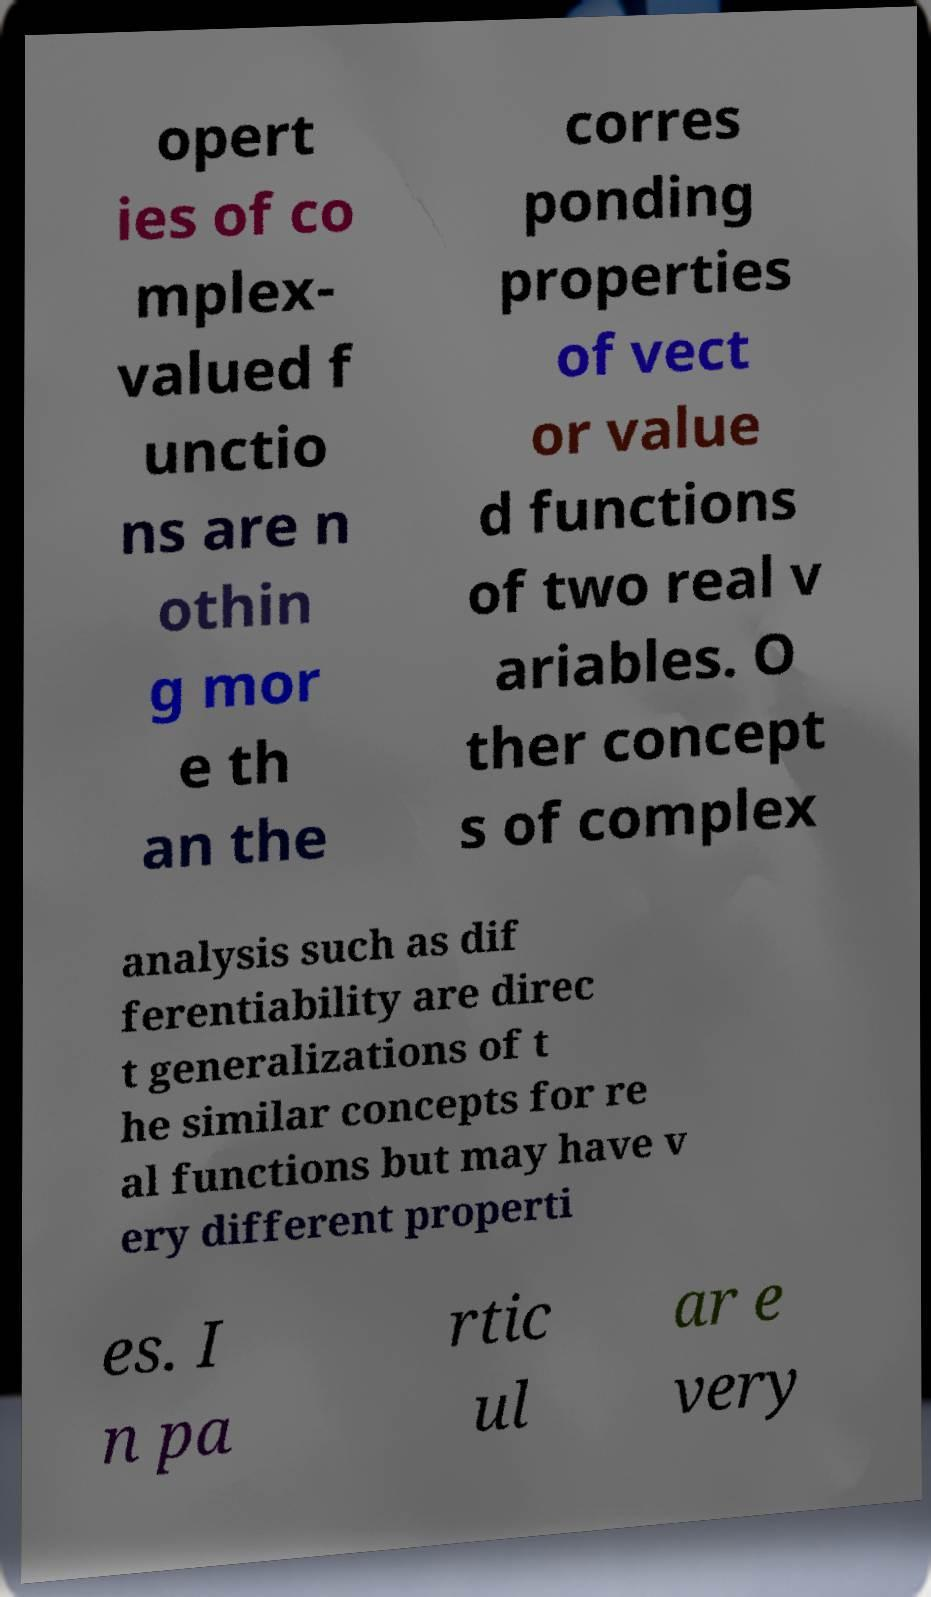There's text embedded in this image that I need extracted. Can you transcribe it verbatim? opert ies of co mplex- valued f unctio ns are n othin g mor e th an the corres ponding properties of vect or value d functions of two real v ariables. O ther concept s of complex analysis such as dif ferentiability are direc t generalizations of t he similar concepts for re al functions but may have v ery different properti es. I n pa rtic ul ar e very 